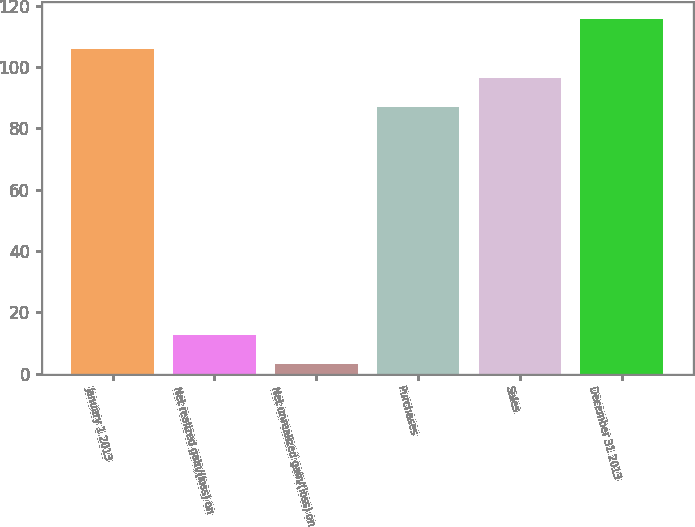<chart> <loc_0><loc_0><loc_500><loc_500><bar_chart><fcel>January 1 2013<fcel>Net realized gain/(loss) on<fcel>Net unrealized gain/(loss) on<fcel>Purchases<fcel>Sales<fcel>December 31 2013<nl><fcel>106<fcel>12.5<fcel>3<fcel>87<fcel>96.5<fcel>115.5<nl></chart> 